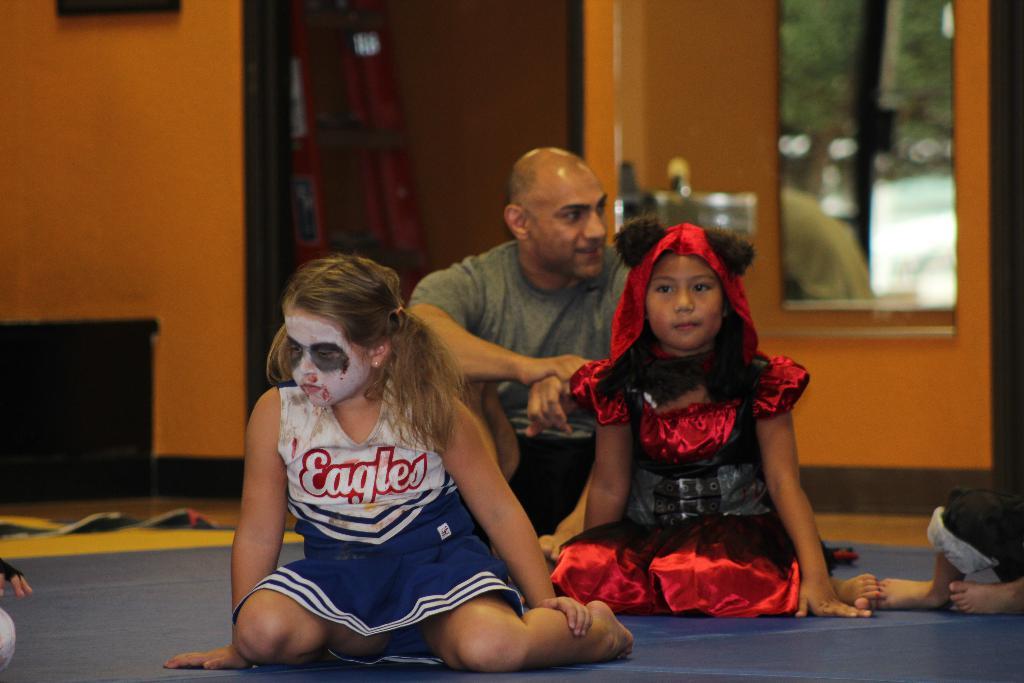What is the name of the scary cheerleader's team?
Your answer should be compact. Eagles. 